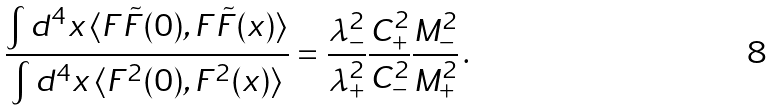Convert formula to latex. <formula><loc_0><loc_0><loc_500><loc_500>\frac { \int d ^ { 4 } x \, \langle F \tilde { F } ( 0 ) , F \tilde { F } ( x ) \rangle } { \int d ^ { 4 } x \, \langle F ^ { 2 } ( 0 ) , F ^ { 2 } ( x ) \rangle } = \frac { \lambda _ { - } ^ { 2 } } { \lambda _ { + } ^ { 2 } } \frac { C _ { + } ^ { 2 } } { C _ { - } ^ { 2 } } \frac { M _ { - } ^ { 2 } } { M _ { + } ^ { 2 } } \, .</formula> 